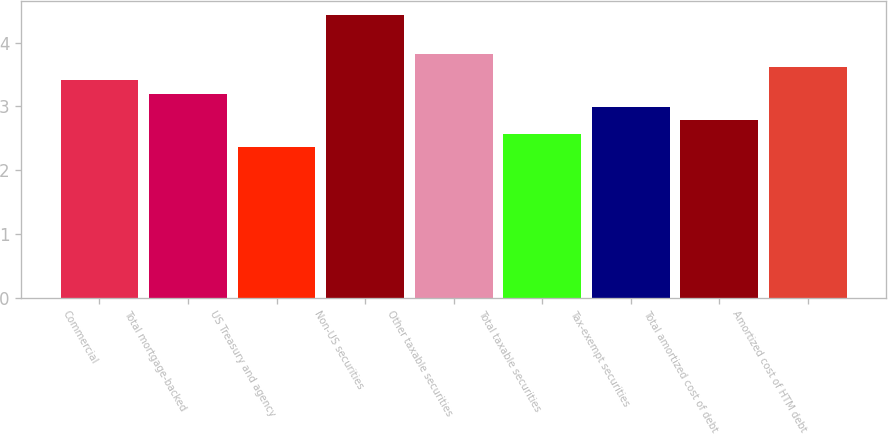Convert chart to OTSL. <chart><loc_0><loc_0><loc_500><loc_500><bar_chart><fcel>Commercial<fcel>Total mortgage-backed<fcel>US Treasury and agency<fcel>Non-US securities<fcel>Other taxable securities<fcel>Total taxable securities<fcel>Tax-exempt securities<fcel>Total amortized cost of debt<fcel>Amortized cost of HTM debt<nl><fcel>3.41<fcel>3.2<fcel>2.36<fcel>4.43<fcel>3.83<fcel>2.57<fcel>2.99<fcel>2.78<fcel>3.62<nl></chart> 